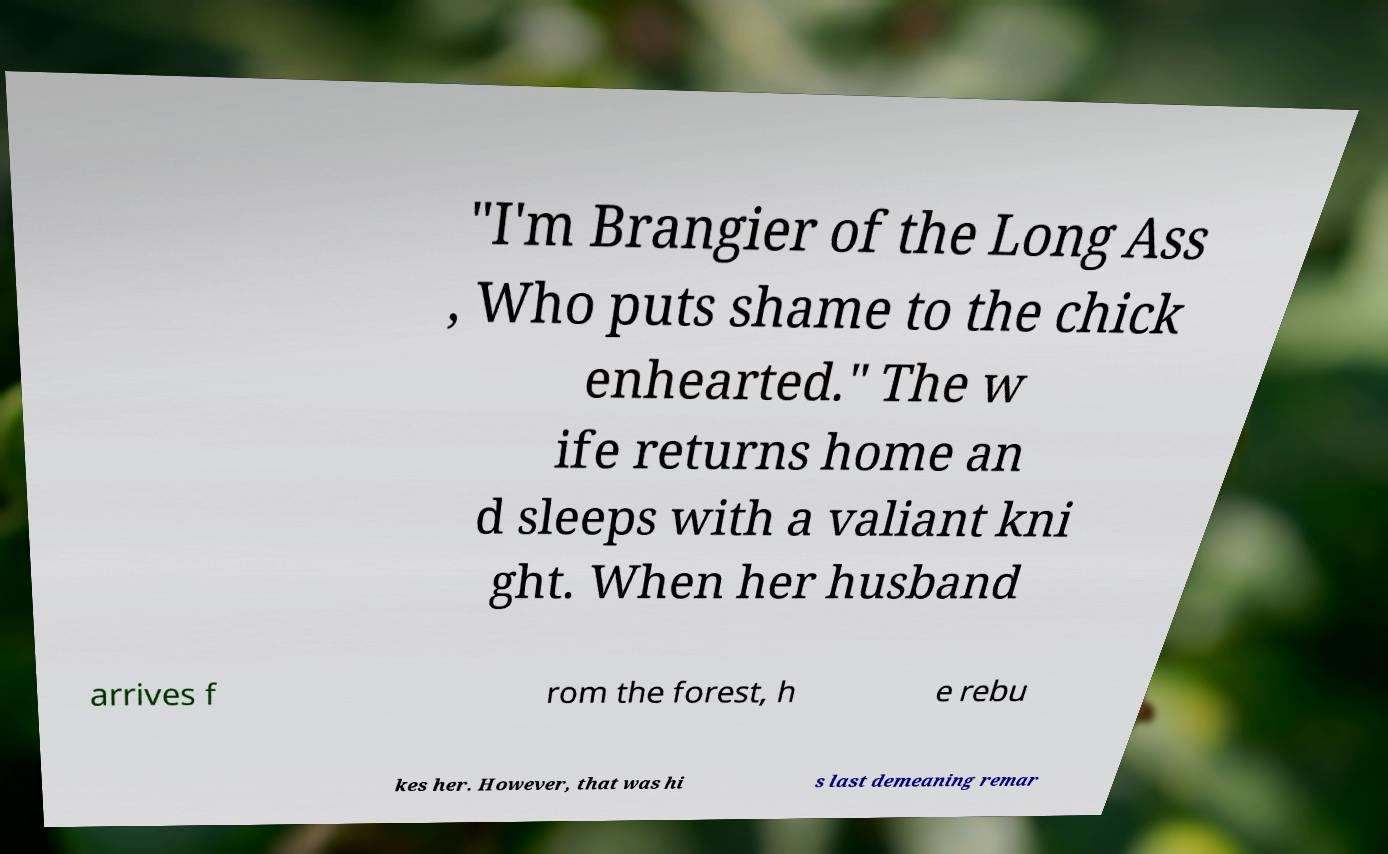Could you assist in decoding the text presented in this image and type it out clearly? "I'm Brangier of the Long Ass , Who puts shame to the chick enhearted." The w ife returns home an d sleeps with a valiant kni ght. When her husband arrives f rom the forest, h e rebu kes her. However, that was hi s last demeaning remar 